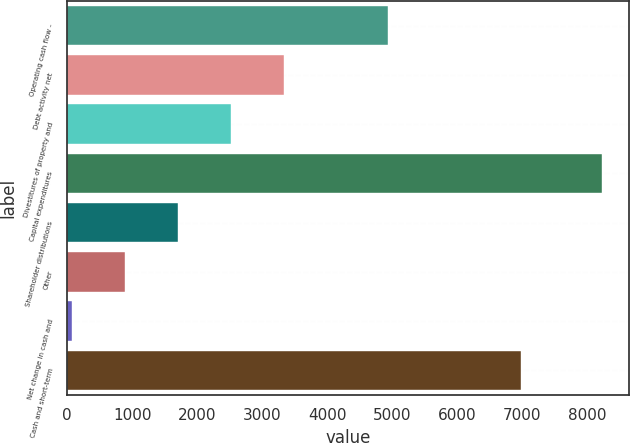Convert chart to OTSL. <chart><loc_0><loc_0><loc_500><loc_500><bar_chart><fcel>Operating cash flow -<fcel>Debt activity net<fcel>Divestitures of property and<fcel>Capital expenditures<fcel>Shareholder distributions<fcel>Other<fcel>Net change in cash and<fcel>Cash and short-term<nl><fcel>4930<fcel>3336.8<fcel>2522.1<fcel>8225<fcel>1707.4<fcel>892.7<fcel>78<fcel>6980<nl></chart> 